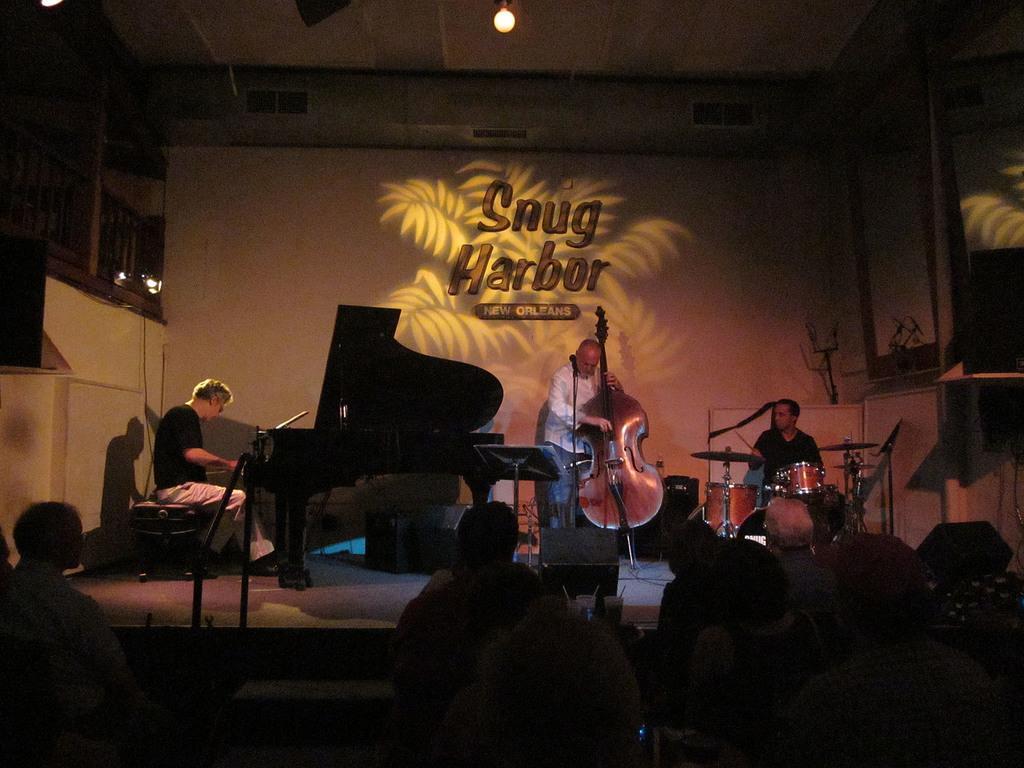Please provide a concise description of this image. In this image we can see some people on the stage holding the musical instruments. We can also see a piano, speaker box, a speaker stand, a mic with a stand and some drums on it. On the bottom of the image we can see a group of people sitting. On the backside we can see a wall with some text on it. 